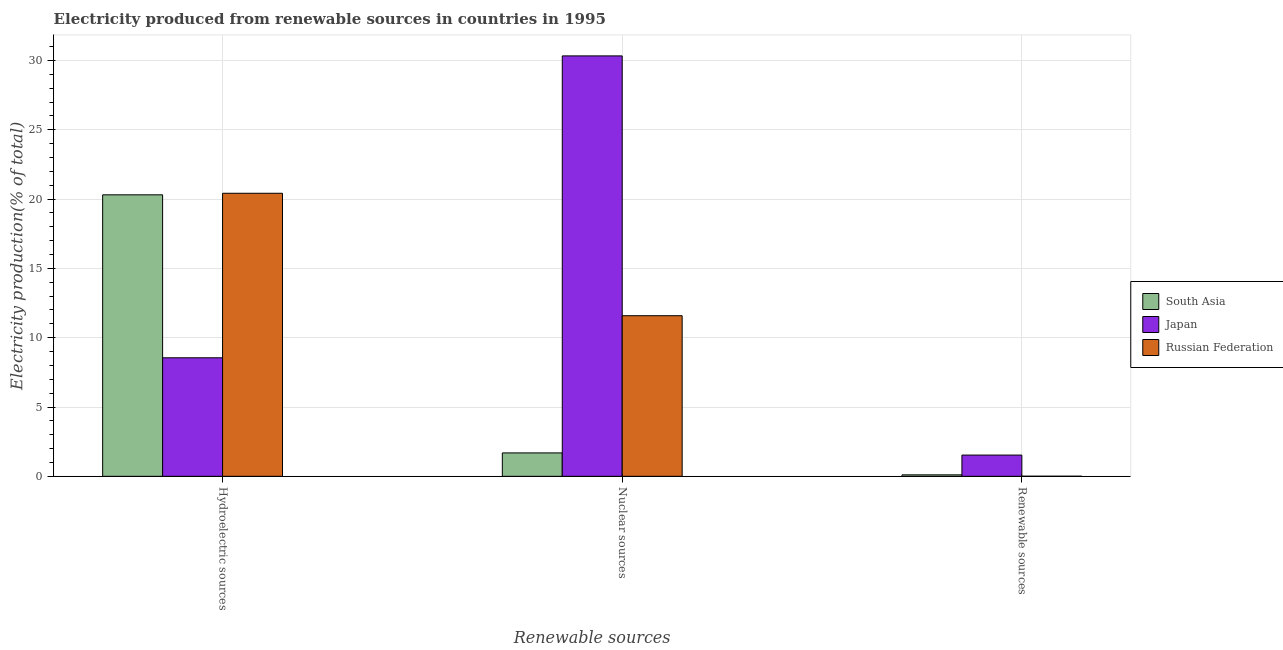How many different coloured bars are there?
Keep it short and to the point. 3. How many groups of bars are there?
Give a very brief answer. 3. How many bars are there on the 1st tick from the left?
Provide a short and direct response. 3. What is the label of the 2nd group of bars from the left?
Your response must be concise. Nuclear sources. What is the percentage of electricity produced by nuclear sources in Japan?
Offer a terse response. 30.33. Across all countries, what is the maximum percentage of electricity produced by hydroelectric sources?
Offer a very short reply. 20.42. Across all countries, what is the minimum percentage of electricity produced by renewable sources?
Your answer should be compact. 0.01. What is the total percentage of electricity produced by hydroelectric sources in the graph?
Provide a succinct answer. 49.28. What is the difference between the percentage of electricity produced by nuclear sources in South Asia and that in Japan?
Offer a very short reply. -28.64. What is the difference between the percentage of electricity produced by renewable sources in South Asia and the percentage of electricity produced by nuclear sources in Japan?
Your response must be concise. -30.22. What is the average percentage of electricity produced by nuclear sources per country?
Make the answer very short. 14.54. What is the difference between the percentage of electricity produced by hydroelectric sources and percentage of electricity produced by renewable sources in Russian Federation?
Your response must be concise. 20.41. What is the ratio of the percentage of electricity produced by hydroelectric sources in Russian Federation to that in Japan?
Your answer should be very brief. 2.39. Is the percentage of electricity produced by nuclear sources in Russian Federation less than that in Japan?
Ensure brevity in your answer.  Yes. Is the difference between the percentage of electricity produced by renewable sources in Russian Federation and Japan greater than the difference between the percentage of electricity produced by hydroelectric sources in Russian Federation and Japan?
Make the answer very short. No. What is the difference between the highest and the second highest percentage of electricity produced by hydroelectric sources?
Make the answer very short. 0.11. What is the difference between the highest and the lowest percentage of electricity produced by nuclear sources?
Ensure brevity in your answer.  28.64. In how many countries, is the percentage of electricity produced by hydroelectric sources greater than the average percentage of electricity produced by hydroelectric sources taken over all countries?
Provide a succinct answer. 2. What does the 1st bar from the left in Hydroelectric sources represents?
Your answer should be very brief. South Asia. What does the 1st bar from the right in Renewable sources represents?
Ensure brevity in your answer.  Russian Federation. How many bars are there?
Give a very brief answer. 9. Are all the bars in the graph horizontal?
Your answer should be compact. No. Does the graph contain grids?
Your answer should be very brief. Yes. Where does the legend appear in the graph?
Provide a succinct answer. Center right. How many legend labels are there?
Provide a succinct answer. 3. What is the title of the graph?
Keep it short and to the point. Electricity produced from renewable sources in countries in 1995. What is the label or title of the X-axis?
Provide a succinct answer. Renewable sources. What is the Electricity production(% of total) of South Asia in Hydroelectric sources?
Give a very brief answer. 20.31. What is the Electricity production(% of total) of Japan in Hydroelectric sources?
Keep it short and to the point. 8.55. What is the Electricity production(% of total) in Russian Federation in Hydroelectric sources?
Your answer should be very brief. 20.42. What is the Electricity production(% of total) of South Asia in Nuclear sources?
Provide a succinct answer. 1.69. What is the Electricity production(% of total) in Japan in Nuclear sources?
Give a very brief answer. 30.33. What is the Electricity production(% of total) in Russian Federation in Nuclear sources?
Give a very brief answer. 11.59. What is the Electricity production(% of total) in South Asia in Renewable sources?
Your answer should be very brief. 0.11. What is the Electricity production(% of total) of Japan in Renewable sources?
Your response must be concise. 1.53. What is the Electricity production(% of total) in Russian Federation in Renewable sources?
Ensure brevity in your answer.  0.01. Across all Renewable sources, what is the maximum Electricity production(% of total) in South Asia?
Offer a terse response. 20.31. Across all Renewable sources, what is the maximum Electricity production(% of total) in Japan?
Your response must be concise. 30.33. Across all Renewable sources, what is the maximum Electricity production(% of total) of Russian Federation?
Your answer should be compact. 20.42. Across all Renewable sources, what is the minimum Electricity production(% of total) of South Asia?
Your answer should be compact. 0.11. Across all Renewable sources, what is the minimum Electricity production(% of total) of Japan?
Your response must be concise. 1.53. Across all Renewable sources, what is the minimum Electricity production(% of total) of Russian Federation?
Your response must be concise. 0.01. What is the total Electricity production(% of total) of South Asia in the graph?
Ensure brevity in your answer.  22.1. What is the total Electricity production(% of total) in Japan in the graph?
Make the answer very short. 40.41. What is the total Electricity production(% of total) of Russian Federation in the graph?
Offer a terse response. 32.01. What is the difference between the Electricity production(% of total) of South Asia in Hydroelectric sources and that in Nuclear sources?
Give a very brief answer. 18.62. What is the difference between the Electricity production(% of total) of Japan in Hydroelectric sources and that in Nuclear sources?
Keep it short and to the point. -21.78. What is the difference between the Electricity production(% of total) in Russian Federation in Hydroelectric sources and that in Nuclear sources?
Offer a very short reply. 8.83. What is the difference between the Electricity production(% of total) in South Asia in Hydroelectric sources and that in Renewable sources?
Your response must be concise. 20.2. What is the difference between the Electricity production(% of total) of Japan in Hydroelectric sources and that in Renewable sources?
Your response must be concise. 7.02. What is the difference between the Electricity production(% of total) in Russian Federation in Hydroelectric sources and that in Renewable sources?
Give a very brief answer. 20.41. What is the difference between the Electricity production(% of total) of South Asia in Nuclear sources and that in Renewable sources?
Give a very brief answer. 1.58. What is the difference between the Electricity production(% of total) of Japan in Nuclear sources and that in Renewable sources?
Your answer should be very brief. 28.8. What is the difference between the Electricity production(% of total) of Russian Federation in Nuclear sources and that in Renewable sources?
Your answer should be compact. 11.58. What is the difference between the Electricity production(% of total) of South Asia in Hydroelectric sources and the Electricity production(% of total) of Japan in Nuclear sources?
Ensure brevity in your answer.  -10.02. What is the difference between the Electricity production(% of total) of South Asia in Hydroelectric sources and the Electricity production(% of total) of Russian Federation in Nuclear sources?
Ensure brevity in your answer.  8.72. What is the difference between the Electricity production(% of total) in Japan in Hydroelectric sources and the Electricity production(% of total) in Russian Federation in Nuclear sources?
Ensure brevity in your answer.  -3.04. What is the difference between the Electricity production(% of total) of South Asia in Hydroelectric sources and the Electricity production(% of total) of Japan in Renewable sources?
Ensure brevity in your answer.  18.77. What is the difference between the Electricity production(% of total) of South Asia in Hydroelectric sources and the Electricity production(% of total) of Russian Federation in Renewable sources?
Offer a terse response. 20.3. What is the difference between the Electricity production(% of total) of Japan in Hydroelectric sources and the Electricity production(% of total) of Russian Federation in Renewable sources?
Your answer should be compact. 8.54. What is the difference between the Electricity production(% of total) of South Asia in Nuclear sources and the Electricity production(% of total) of Japan in Renewable sources?
Make the answer very short. 0.16. What is the difference between the Electricity production(% of total) of South Asia in Nuclear sources and the Electricity production(% of total) of Russian Federation in Renewable sources?
Keep it short and to the point. 1.68. What is the difference between the Electricity production(% of total) in Japan in Nuclear sources and the Electricity production(% of total) in Russian Federation in Renewable sources?
Keep it short and to the point. 30.32. What is the average Electricity production(% of total) in South Asia per Renewable sources?
Ensure brevity in your answer.  7.37. What is the average Electricity production(% of total) of Japan per Renewable sources?
Provide a succinct answer. 13.47. What is the average Electricity production(% of total) of Russian Federation per Renewable sources?
Offer a terse response. 10.67. What is the difference between the Electricity production(% of total) of South Asia and Electricity production(% of total) of Japan in Hydroelectric sources?
Provide a short and direct response. 11.76. What is the difference between the Electricity production(% of total) in South Asia and Electricity production(% of total) in Russian Federation in Hydroelectric sources?
Ensure brevity in your answer.  -0.11. What is the difference between the Electricity production(% of total) in Japan and Electricity production(% of total) in Russian Federation in Hydroelectric sources?
Your response must be concise. -11.87. What is the difference between the Electricity production(% of total) of South Asia and Electricity production(% of total) of Japan in Nuclear sources?
Provide a short and direct response. -28.64. What is the difference between the Electricity production(% of total) in South Asia and Electricity production(% of total) in Russian Federation in Nuclear sources?
Provide a succinct answer. -9.9. What is the difference between the Electricity production(% of total) in Japan and Electricity production(% of total) in Russian Federation in Nuclear sources?
Your answer should be very brief. 18.74. What is the difference between the Electricity production(% of total) in South Asia and Electricity production(% of total) in Japan in Renewable sources?
Offer a very short reply. -1.43. What is the difference between the Electricity production(% of total) in South Asia and Electricity production(% of total) in Russian Federation in Renewable sources?
Your answer should be very brief. 0.1. What is the difference between the Electricity production(% of total) of Japan and Electricity production(% of total) of Russian Federation in Renewable sources?
Your answer should be very brief. 1.53. What is the ratio of the Electricity production(% of total) of South Asia in Hydroelectric sources to that in Nuclear sources?
Provide a succinct answer. 12.02. What is the ratio of the Electricity production(% of total) of Japan in Hydroelectric sources to that in Nuclear sources?
Your response must be concise. 0.28. What is the ratio of the Electricity production(% of total) of Russian Federation in Hydroelectric sources to that in Nuclear sources?
Keep it short and to the point. 1.76. What is the ratio of the Electricity production(% of total) of South Asia in Hydroelectric sources to that in Renewable sources?
Offer a terse response. 192.05. What is the ratio of the Electricity production(% of total) of Japan in Hydroelectric sources to that in Renewable sources?
Ensure brevity in your answer.  5.58. What is the ratio of the Electricity production(% of total) in Russian Federation in Hydroelectric sources to that in Renewable sources?
Keep it short and to the point. 2973.07. What is the ratio of the Electricity production(% of total) of South Asia in Nuclear sources to that in Renewable sources?
Offer a very short reply. 15.97. What is the ratio of the Electricity production(% of total) of Japan in Nuclear sources to that in Renewable sources?
Your answer should be compact. 19.78. What is the ratio of the Electricity production(% of total) of Russian Federation in Nuclear sources to that in Renewable sources?
Ensure brevity in your answer.  1686.98. What is the difference between the highest and the second highest Electricity production(% of total) in South Asia?
Your answer should be very brief. 18.62. What is the difference between the highest and the second highest Electricity production(% of total) in Japan?
Provide a succinct answer. 21.78. What is the difference between the highest and the second highest Electricity production(% of total) in Russian Federation?
Provide a short and direct response. 8.83. What is the difference between the highest and the lowest Electricity production(% of total) of South Asia?
Ensure brevity in your answer.  20.2. What is the difference between the highest and the lowest Electricity production(% of total) in Japan?
Keep it short and to the point. 28.8. What is the difference between the highest and the lowest Electricity production(% of total) in Russian Federation?
Provide a succinct answer. 20.41. 